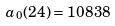<formula> <loc_0><loc_0><loc_500><loc_500>a _ { 0 } ( 2 4 ) = 1 0 8 3 8</formula> 